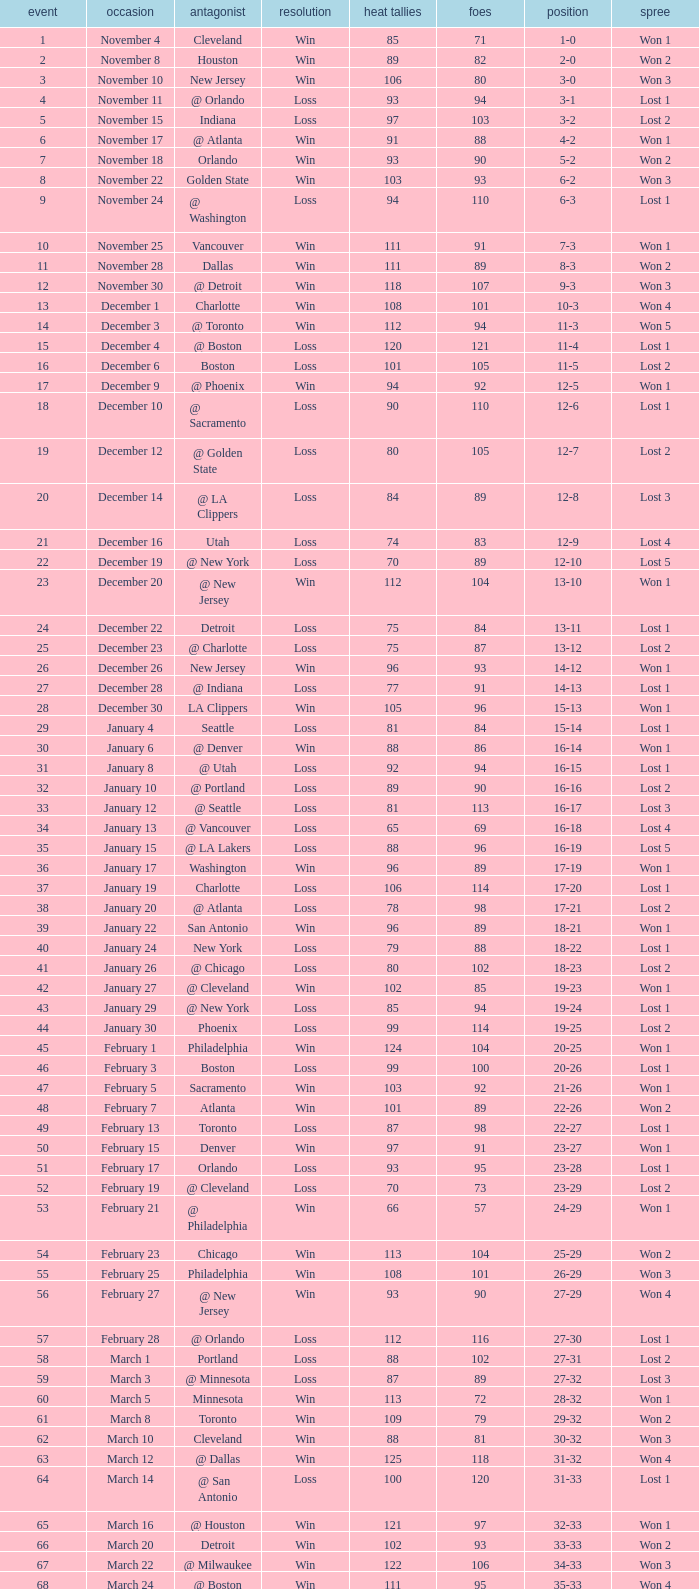What is Heat Points, when Game is less than 80, and when Date is "April 26 (First Round)"? 85.0. 